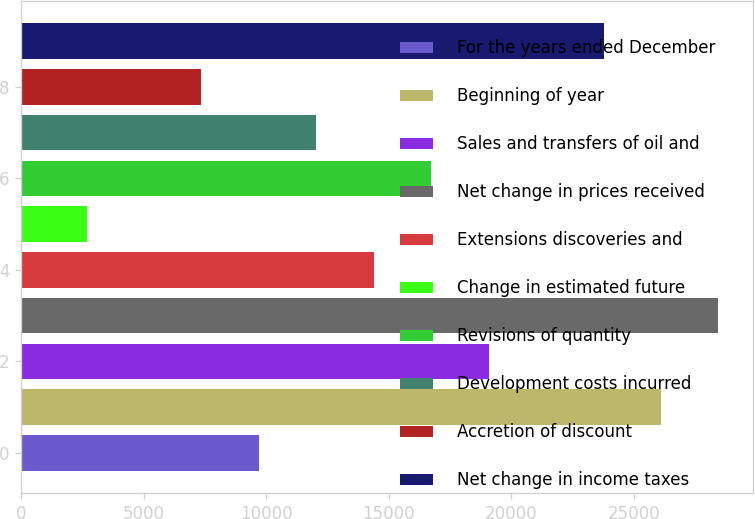<chart> <loc_0><loc_0><loc_500><loc_500><bar_chart><fcel>For the years ended December<fcel>Beginning of year<fcel>Sales and transfers of oil and<fcel>Net change in prices received<fcel>Extensions discoveries and<fcel>Change in estimated future<fcel>Revisions of quantity<fcel>Development costs incurred<fcel>Accretion of discount<fcel>Net change in income taxes<nl><fcel>9697.4<fcel>26099.1<fcel>19069.8<fcel>28442.2<fcel>14383.6<fcel>2668.1<fcel>16726.7<fcel>12040.5<fcel>7354.3<fcel>23756<nl></chart> 